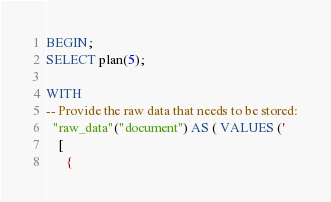Convert code to text. <code><loc_0><loc_0><loc_500><loc_500><_SQL_>BEGIN;
SELECT plan(5);

WITH
-- Provide the raw data that needs to be stored:
  "raw_data"("document") AS ( VALUES ('
    [
      {</code> 